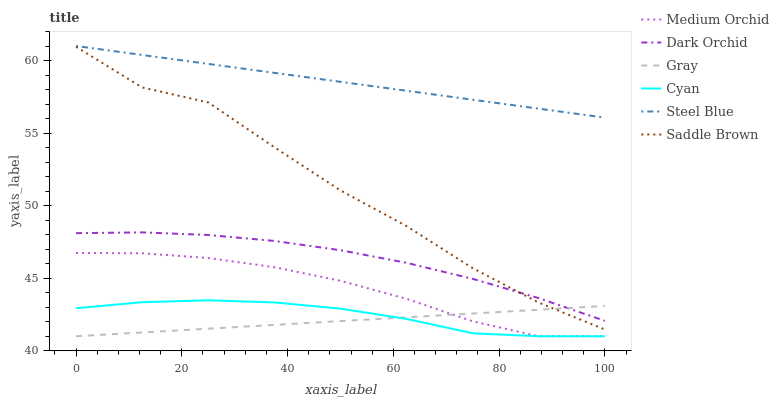Does Medium Orchid have the minimum area under the curve?
Answer yes or no. No. Does Medium Orchid have the maximum area under the curve?
Answer yes or no. No. Is Medium Orchid the smoothest?
Answer yes or no. No. Is Medium Orchid the roughest?
Answer yes or no. No. Does Steel Blue have the lowest value?
Answer yes or no. No. Does Medium Orchid have the highest value?
Answer yes or no. No. Is Cyan less than Dark Orchid?
Answer yes or no. Yes. Is Saddle Brown greater than Cyan?
Answer yes or no. Yes. Does Cyan intersect Dark Orchid?
Answer yes or no. No. 